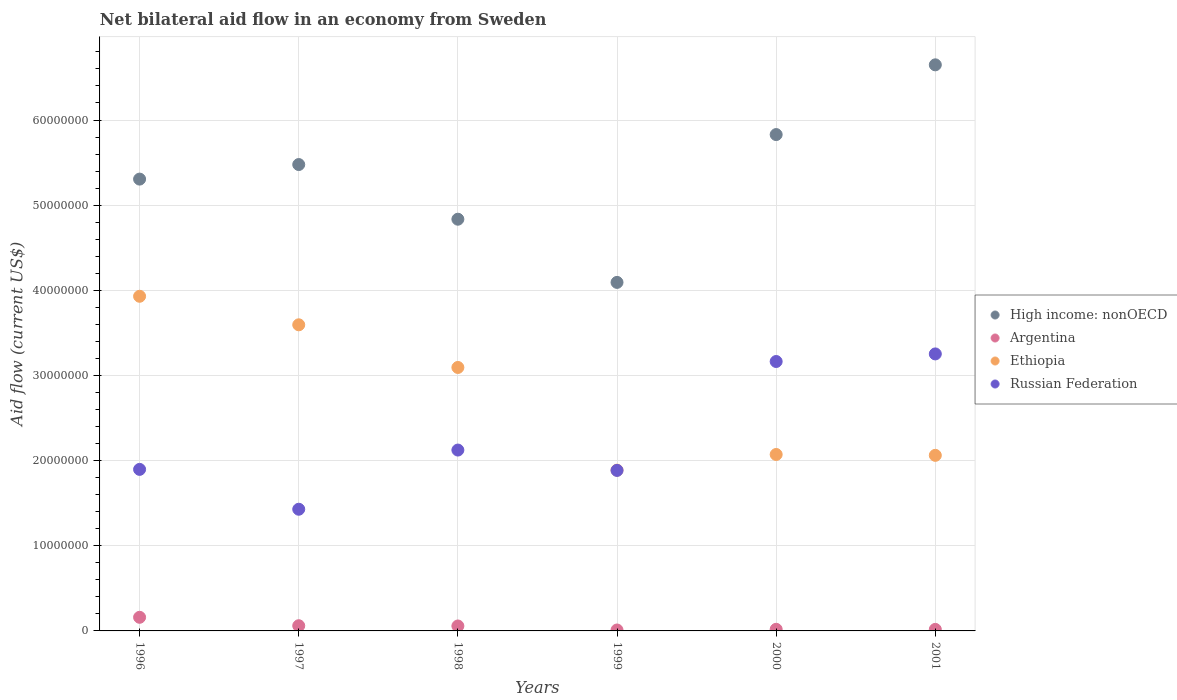How many different coloured dotlines are there?
Offer a very short reply. 4. Is the number of dotlines equal to the number of legend labels?
Make the answer very short. Yes. What is the net bilateral aid flow in Ethiopia in 2000?
Provide a short and direct response. 2.07e+07. Across all years, what is the maximum net bilateral aid flow in Ethiopia?
Offer a terse response. 3.93e+07. Across all years, what is the minimum net bilateral aid flow in High income: nonOECD?
Your response must be concise. 4.09e+07. In which year was the net bilateral aid flow in Ethiopia maximum?
Offer a very short reply. 1996. In which year was the net bilateral aid flow in Argentina minimum?
Offer a very short reply. 1999. What is the total net bilateral aid flow in Ethiopia in the graph?
Ensure brevity in your answer.  1.66e+08. What is the difference between the net bilateral aid flow in High income: nonOECD in 1999 and the net bilateral aid flow in Ethiopia in 1996?
Give a very brief answer. 1.63e+06. What is the average net bilateral aid flow in High income: nonOECD per year?
Your answer should be compact. 5.36e+07. In the year 1999, what is the difference between the net bilateral aid flow in Russian Federation and net bilateral aid flow in Argentina?
Give a very brief answer. 1.87e+07. What is the ratio of the net bilateral aid flow in Russian Federation in 1996 to that in 2000?
Ensure brevity in your answer.  0.6. What is the difference between the highest and the second highest net bilateral aid flow in High income: nonOECD?
Your answer should be very brief. 8.19e+06. What is the difference between the highest and the lowest net bilateral aid flow in Ethiopia?
Your response must be concise. 2.04e+07. In how many years, is the net bilateral aid flow in High income: nonOECD greater than the average net bilateral aid flow in High income: nonOECD taken over all years?
Provide a succinct answer. 3. Is the sum of the net bilateral aid flow in High income: nonOECD in 1996 and 1999 greater than the maximum net bilateral aid flow in Argentina across all years?
Provide a short and direct response. Yes. Is the net bilateral aid flow in Argentina strictly greater than the net bilateral aid flow in High income: nonOECD over the years?
Offer a terse response. No. Is the net bilateral aid flow in Russian Federation strictly less than the net bilateral aid flow in High income: nonOECD over the years?
Offer a terse response. Yes. How many dotlines are there?
Give a very brief answer. 4. How many years are there in the graph?
Keep it short and to the point. 6. Are the values on the major ticks of Y-axis written in scientific E-notation?
Give a very brief answer. No. Does the graph contain grids?
Make the answer very short. Yes. How are the legend labels stacked?
Your response must be concise. Vertical. What is the title of the graph?
Your answer should be compact. Net bilateral aid flow in an economy from Sweden. Does "Haiti" appear as one of the legend labels in the graph?
Provide a succinct answer. No. What is the label or title of the Y-axis?
Provide a short and direct response. Aid flow (current US$). What is the Aid flow (current US$) of High income: nonOECD in 1996?
Offer a terse response. 5.31e+07. What is the Aid flow (current US$) of Argentina in 1996?
Offer a terse response. 1.60e+06. What is the Aid flow (current US$) in Ethiopia in 1996?
Give a very brief answer. 3.93e+07. What is the Aid flow (current US$) in Russian Federation in 1996?
Offer a terse response. 1.90e+07. What is the Aid flow (current US$) of High income: nonOECD in 1997?
Make the answer very short. 5.48e+07. What is the Aid flow (current US$) in Ethiopia in 1997?
Your response must be concise. 3.60e+07. What is the Aid flow (current US$) in Russian Federation in 1997?
Offer a very short reply. 1.43e+07. What is the Aid flow (current US$) of High income: nonOECD in 1998?
Offer a terse response. 4.84e+07. What is the Aid flow (current US$) in Argentina in 1998?
Your answer should be very brief. 5.80e+05. What is the Aid flow (current US$) in Ethiopia in 1998?
Offer a terse response. 3.09e+07. What is the Aid flow (current US$) of Russian Federation in 1998?
Make the answer very short. 2.12e+07. What is the Aid flow (current US$) in High income: nonOECD in 1999?
Ensure brevity in your answer.  4.09e+07. What is the Aid flow (current US$) of Ethiopia in 1999?
Make the answer very short. 1.89e+07. What is the Aid flow (current US$) in Russian Federation in 1999?
Ensure brevity in your answer.  1.88e+07. What is the Aid flow (current US$) of High income: nonOECD in 2000?
Provide a short and direct response. 5.83e+07. What is the Aid flow (current US$) in Ethiopia in 2000?
Ensure brevity in your answer.  2.07e+07. What is the Aid flow (current US$) of Russian Federation in 2000?
Ensure brevity in your answer.  3.16e+07. What is the Aid flow (current US$) in High income: nonOECD in 2001?
Provide a succinct answer. 6.65e+07. What is the Aid flow (current US$) of Argentina in 2001?
Keep it short and to the point. 1.80e+05. What is the Aid flow (current US$) of Ethiopia in 2001?
Your answer should be compact. 2.06e+07. What is the Aid flow (current US$) in Russian Federation in 2001?
Provide a succinct answer. 3.25e+07. Across all years, what is the maximum Aid flow (current US$) in High income: nonOECD?
Your answer should be compact. 6.65e+07. Across all years, what is the maximum Aid flow (current US$) in Argentina?
Your answer should be very brief. 1.60e+06. Across all years, what is the maximum Aid flow (current US$) of Ethiopia?
Provide a short and direct response. 3.93e+07. Across all years, what is the maximum Aid flow (current US$) in Russian Federation?
Ensure brevity in your answer.  3.25e+07. Across all years, what is the minimum Aid flow (current US$) in High income: nonOECD?
Make the answer very short. 4.09e+07. Across all years, what is the minimum Aid flow (current US$) in Ethiopia?
Offer a terse response. 1.89e+07. Across all years, what is the minimum Aid flow (current US$) in Russian Federation?
Ensure brevity in your answer.  1.43e+07. What is the total Aid flow (current US$) in High income: nonOECD in the graph?
Your response must be concise. 3.22e+08. What is the total Aid flow (current US$) in Argentina in the graph?
Make the answer very short. 3.27e+06. What is the total Aid flow (current US$) of Ethiopia in the graph?
Your response must be concise. 1.66e+08. What is the total Aid flow (current US$) in Russian Federation in the graph?
Your answer should be very brief. 1.38e+08. What is the difference between the Aid flow (current US$) of High income: nonOECD in 1996 and that in 1997?
Your answer should be very brief. -1.71e+06. What is the difference between the Aid flow (current US$) of Argentina in 1996 and that in 1997?
Your answer should be very brief. 9.90e+05. What is the difference between the Aid flow (current US$) of Ethiopia in 1996 and that in 1997?
Your answer should be compact. 3.35e+06. What is the difference between the Aid flow (current US$) in Russian Federation in 1996 and that in 1997?
Offer a terse response. 4.68e+06. What is the difference between the Aid flow (current US$) of High income: nonOECD in 1996 and that in 1998?
Your answer should be compact. 4.71e+06. What is the difference between the Aid flow (current US$) in Argentina in 1996 and that in 1998?
Keep it short and to the point. 1.02e+06. What is the difference between the Aid flow (current US$) of Ethiopia in 1996 and that in 1998?
Ensure brevity in your answer.  8.36e+06. What is the difference between the Aid flow (current US$) of Russian Federation in 1996 and that in 1998?
Your response must be concise. -2.27e+06. What is the difference between the Aid flow (current US$) of High income: nonOECD in 1996 and that in 1999?
Make the answer very short. 1.21e+07. What is the difference between the Aid flow (current US$) of Argentina in 1996 and that in 1999?
Your answer should be very brief. 1.49e+06. What is the difference between the Aid flow (current US$) of Ethiopia in 1996 and that in 1999?
Your response must be concise. 2.04e+07. What is the difference between the Aid flow (current US$) in Russian Federation in 1996 and that in 1999?
Your answer should be very brief. 1.20e+05. What is the difference between the Aid flow (current US$) of High income: nonOECD in 1996 and that in 2000?
Provide a short and direct response. -5.23e+06. What is the difference between the Aid flow (current US$) of Argentina in 1996 and that in 2000?
Your response must be concise. 1.41e+06. What is the difference between the Aid flow (current US$) of Ethiopia in 1996 and that in 2000?
Provide a short and direct response. 1.86e+07. What is the difference between the Aid flow (current US$) of Russian Federation in 1996 and that in 2000?
Make the answer very short. -1.27e+07. What is the difference between the Aid flow (current US$) of High income: nonOECD in 1996 and that in 2001?
Provide a short and direct response. -1.34e+07. What is the difference between the Aid flow (current US$) of Argentina in 1996 and that in 2001?
Make the answer very short. 1.42e+06. What is the difference between the Aid flow (current US$) of Ethiopia in 1996 and that in 2001?
Offer a terse response. 1.87e+07. What is the difference between the Aid flow (current US$) of Russian Federation in 1996 and that in 2001?
Offer a terse response. -1.36e+07. What is the difference between the Aid flow (current US$) of High income: nonOECD in 1997 and that in 1998?
Provide a short and direct response. 6.42e+06. What is the difference between the Aid flow (current US$) in Ethiopia in 1997 and that in 1998?
Your answer should be very brief. 5.01e+06. What is the difference between the Aid flow (current US$) in Russian Federation in 1997 and that in 1998?
Give a very brief answer. -6.95e+06. What is the difference between the Aid flow (current US$) in High income: nonOECD in 1997 and that in 1999?
Your answer should be very brief. 1.38e+07. What is the difference between the Aid flow (current US$) in Ethiopia in 1997 and that in 1999?
Ensure brevity in your answer.  1.71e+07. What is the difference between the Aid flow (current US$) in Russian Federation in 1997 and that in 1999?
Offer a terse response. -4.56e+06. What is the difference between the Aid flow (current US$) in High income: nonOECD in 1997 and that in 2000?
Offer a terse response. -3.52e+06. What is the difference between the Aid flow (current US$) of Ethiopia in 1997 and that in 2000?
Give a very brief answer. 1.52e+07. What is the difference between the Aid flow (current US$) in Russian Federation in 1997 and that in 2000?
Keep it short and to the point. -1.74e+07. What is the difference between the Aid flow (current US$) of High income: nonOECD in 1997 and that in 2001?
Ensure brevity in your answer.  -1.17e+07. What is the difference between the Aid flow (current US$) in Ethiopia in 1997 and that in 2001?
Your response must be concise. 1.53e+07. What is the difference between the Aid flow (current US$) in Russian Federation in 1997 and that in 2001?
Offer a very short reply. -1.82e+07. What is the difference between the Aid flow (current US$) of High income: nonOECD in 1998 and that in 1999?
Give a very brief answer. 7.42e+06. What is the difference between the Aid flow (current US$) in Argentina in 1998 and that in 1999?
Keep it short and to the point. 4.70e+05. What is the difference between the Aid flow (current US$) of Ethiopia in 1998 and that in 1999?
Give a very brief answer. 1.21e+07. What is the difference between the Aid flow (current US$) of Russian Federation in 1998 and that in 1999?
Make the answer very short. 2.39e+06. What is the difference between the Aid flow (current US$) of High income: nonOECD in 1998 and that in 2000?
Your response must be concise. -9.94e+06. What is the difference between the Aid flow (current US$) of Argentina in 1998 and that in 2000?
Keep it short and to the point. 3.90e+05. What is the difference between the Aid flow (current US$) of Ethiopia in 1998 and that in 2000?
Keep it short and to the point. 1.02e+07. What is the difference between the Aid flow (current US$) of Russian Federation in 1998 and that in 2000?
Keep it short and to the point. -1.04e+07. What is the difference between the Aid flow (current US$) in High income: nonOECD in 1998 and that in 2001?
Your response must be concise. -1.81e+07. What is the difference between the Aid flow (current US$) in Ethiopia in 1998 and that in 2001?
Your answer should be compact. 1.03e+07. What is the difference between the Aid flow (current US$) in Russian Federation in 1998 and that in 2001?
Provide a short and direct response. -1.13e+07. What is the difference between the Aid flow (current US$) of High income: nonOECD in 1999 and that in 2000?
Provide a succinct answer. -1.74e+07. What is the difference between the Aid flow (current US$) in Ethiopia in 1999 and that in 2000?
Your answer should be compact. -1.84e+06. What is the difference between the Aid flow (current US$) of Russian Federation in 1999 and that in 2000?
Make the answer very short. -1.28e+07. What is the difference between the Aid flow (current US$) in High income: nonOECD in 1999 and that in 2001?
Your response must be concise. -2.56e+07. What is the difference between the Aid flow (current US$) in Argentina in 1999 and that in 2001?
Provide a short and direct response. -7.00e+04. What is the difference between the Aid flow (current US$) of Ethiopia in 1999 and that in 2001?
Provide a succinct answer. -1.74e+06. What is the difference between the Aid flow (current US$) in Russian Federation in 1999 and that in 2001?
Keep it short and to the point. -1.37e+07. What is the difference between the Aid flow (current US$) of High income: nonOECD in 2000 and that in 2001?
Offer a very short reply. -8.19e+06. What is the difference between the Aid flow (current US$) of Argentina in 2000 and that in 2001?
Provide a short and direct response. 10000. What is the difference between the Aid flow (current US$) in Ethiopia in 2000 and that in 2001?
Make the answer very short. 1.00e+05. What is the difference between the Aid flow (current US$) of Russian Federation in 2000 and that in 2001?
Your answer should be very brief. -8.90e+05. What is the difference between the Aid flow (current US$) in High income: nonOECD in 1996 and the Aid flow (current US$) in Argentina in 1997?
Your answer should be very brief. 5.24e+07. What is the difference between the Aid flow (current US$) in High income: nonOECD in 1996 and the Aid flow (current US$) in Ethiopia in 1997?
Make the answer very short. 1.71e+07. What is the difference between the Aid flow (current US$) in High income: nonOECD in 1996 and the Aid flow (current US$) in Russian Federation in 1997?
Make the answer very short. 3.88e+07. What is the difference between the Aid flow (current US$) of Argentina in 1996 and the Aid flow (current US$) of Ethiopia in 1997?
Offer a terse response. -3.44e+07. What is the difference between the Aid flow (current US$) in Argentina in 1996 and the Aid flow (current US$) in Russian Federation in 1997?
Offer a very short reply. -1.27e+07. What is the difference between the Aid flow (current US$) in Ethiopia in 1996 and the Aid flow (current US$) in Russian Federation in 1997?
Ensure brevity in your answer.  2.50e+07. What is the difference between the Aid flow (current US$) in High income: nonOECD in 1996 and the Aid flow (current US$) in Argentina in 1998?
Your response must be concise. 5.25e+07. What is the difference between the Aid flow (current US$) in High income: nonOECD in 1996 and the Aid flow (current US$) in Ethiopia in 1998?
Your answer should be compact. 2.21e+07. What is the difference between the Aid flow (current US$) of High income: nonOECD in 1996 and the Aid flow (current US$) of Russian Federation in 1998?
Offer a very short reply. 3.18e+07. What is the difference between the Aid flow (current US$) of Argentina in 1996 and the Aid flow (current US$) of Ethiopia in 1998?
Make the answer very short. -2.93e+07. What is the difference between the Aid flow (current US$) of Argentina in 1996 and the Aid flow (current US$) of Russian Federation in 1998?
Give a very brief answer. -1.96e+07. What is the difference between the Aid flow (current US$) in Ethiopia in 1996 and the Aid flow (current US$) in Russian Federation in 1998?
Ensure brevity in your answer.  1.81e+07. What is the difference between the Aid flow (current US$) in High income: nonOECD in 1996 and the Aid flow (current US$) in Argentina in 1999?
Offer a very short reply. 5.30e+07. What is the difference between the Aid flow (current US$) in High income: nonOECD in 1996 and the Aid flow (current US$) in Ethiopia in 1999?
Keep it short and to the point. 3.42e+07. What is the difference between the Aid flow (current US$) of High income: nonOECD in 1996 and the Aid flow (current US$) of Russian Federation in 1999?
Give a very brief answer. 3.42e+07. What is the difference between the Aid flow (current US$) of Argentina in 1996 and the Aid flow (current US$) of Ethiopia in 1999?
Provide a succinct answer. -1.73e+07. What is the difference between the Aid flow (current US$) in Argentina in 1996 and the Aid flow (current US$) in Russian Federation in 1999?
Your response must be concise. -1.72e+07. What is the difference between the Aid flow (current US$) of Ethiopia in 1996 and the Aid flow (current US$) of Russian Federation in 1999?
Offer a very short reply. 2.04e+07. What is the difference between the Aid flow (current US$) in High income: nonOECD in 1996 and the Aid flow (current US$) in Argentina in 2000?
Your answer should be compact. 5.29e+07. What is the difference between the Aid flow (current US$) of High income: nonOECD in 1996 and the Aid flow (current US$) of Ethiopia in 2000?
Offer a terse response. 3.23e+07. What is the difference between the Aid flow (current US$) of High income: nonOECD in 1996 and the Aid flow (current US$) of Russian Federation in 2000?
Provide a short and direct response. 2.14e+07. What is the difference between the Aid flow (current US$) in Argentina in 1996 and the Aid flow (current US$) in Ethiopia in 2000?
Make the answer very short. -1.91e+07. What is the difference between the Aid flow (current US$) of Argentina in 1996 and the Aid flow (current US$) of Russian Federation in 2000?
Your answer should be very brief. -3.00e+07. What is the difference between the Aid flow (current US$) in Ethiopia in 1996 and the Aid flow (current US$) in Russian Federation in 2000?
Provide a short and direct response. 7.66e+06. What is the difference between the Aid flow (current US$) of High income: nonOECD in 1996 and the Aid flow (current US$) of Argentina in 2001?
Give a very brief answer. 5.29e+07. What is the difference between the Aid flow (current US$) in High income: nonOECD in 1996 and the Aid flow (current US$) in Ethiopia in 2001?
Give a very brief answer. 3.24e+07. What is the difference between the Aid flow (current US$) in High income: nonOECD in 1996 and the Aid flow (current US$) in Russian Federation in 2001?
Offer a terse response. 2.05e+07. What is the difference between the Aid flow (current US$) of Argentina in 1996 and the Aid flow (current US$) of Ethiopia in 2001?
Offer a very short reply. -1.90e+07. What is the difference between the Aid flow (current US$) of Argentina in 1996 and the Aid flow (current US$) of Russian Federation in 2001?
Your answer should be compact. -3.09e+07. What is the difference between the Aid flow (current US$) in Ethiopia in 1996 and the Aid flow (current US$) in Russian Federation in 2001?
Ensure brevity in your answer.  6.77e+06. What is the difference between the Aid flow (current US$) in High income: nonOECD in 1997 and the Aid flow (current US$) in Argentina in 1998?
Provide a short and direct response. 5.42e+07. What is the difference between the Aid flow (current US$) in High income: nonOECD in 1997 and the Aid flow (current US$) in Ethiopia in 1998?
Ensure brevity in your answer.  2.38e+07. What is the difference between the Aid flow (current US$) in High income: nonOECD in 1997 and the Aid flow (current US$) in Russian Federation in 1998?
Your answer should be very brief. 3.35e+07. What is the difference between the Aid flow (current US$) in Argentina in 1997 and the Aid flow (current US$) in Ethiopia in 1998?
Offer a terse response. -3.03e+07. What is the difference between the Aid flow (current US$) of Argentina in 1997 and the Aid flow (current US$) of Russian Federation in 1998?
Make the answer very short. -2.06e+07. What is the difference between the Aid flow (current US$) of Ethiopia in 1997 and the Aid flow (current US$) of Russian Federation in 1998?
Provide a short and direct response. 1.47e+07. What is the difference between the Aid flow (current US$) of High income: nonOECD in 1997 and the Aid flow (current US$) of Argentina in 1999?
Provide a short and direct response. 5.47e+07. What is the difference between the Aid flow (current US$) in High income: nonOECD in 1997 and the Aid flow (current US$) in Ethiopia in 1999?
Offer a very short reply. 3.59e+07. What is the difference between the Aid flow (current US$) in High income: nonOECD in 1997 and the Aid flow (current US$) in Russian Federation in 1999?
Make the answer very short. 3.59e+07. What is the difference between the Aid flow (current US$) of Argentina in 1997 and the Aid flow (current US$) of Ethiopia in 1999?
Keep it short and to the point. -1.83e+07. What is the difference between the Aid flow (current US$) of Argentina in 1997 and the Aid flow (current US$) of Russian Federation in 1999?
Make the answer very short. -1.82e+07. What is the difference between the Aid flow (current US$) of Ethiopia in 1997 and the Aid flow (current US$) of Russian Federation in 1999?
Offer a terse response. 1.71e+07. What is the difference between the Aid flow (current US$) of High income: nonOECD in 1997 and the Aid flow (current US$) of Argentina in 2000?
Offer a very short reply. 5.46e+07. What is the difference between the Aid flow (current US$) in High income: nonOECD in 1997 and the Aid flow (current US$) in Ethiopia in 2000?
Offer a terse response. 3.40e+07. What is the difference between the Aid flow (current US$) of High income: nonOECD in 1997 and the Aid flow (current US$) of Russian Federation in 2000?
Make the answer very short. 2.31e+07. What is the difference between the Aid flow (current US$) of Argentina in 1997 and the Aid flow (current US$) of Ethiopia in 2000?
Provide a short and direct response. -2.01e+07. What is the difference between the Aid flow (current US$) in Argentina in 1997 and the Aid flow (current US$) in Russian Federation in 2000?
Give a very brief answer. -3.10e+07. What is the difference between the Aid flow (current US$) in Ethiopia in 1997 and the Aid flow (current US$) in Russian Federation in 2000?
Offer a very short reply. 4.31e+06. What is the difference between the Aid flow (current US$) in High income: nonOECD in 1997 and the Aid flow (current US$) in Argentina in 2001?
Make the answer very short. 5.46e+07. What is the difference between the Aid flow (current US$) of High income: nonOECD in 1997 and the Aid flow (current US$) of Ethiopia in 2001?
Offer a terse response. 3.42e+07. What is the difference between the Aid flow (current US$) of High income: nonOECD in 1997 and the Aid flow (current US$) of Russian Federation in 2001?
Keep it short and to the point. 2.22e+07. What is the difference between the Aid flow (current US$) of Argentina in 1997 and the Aid flow (current US$) of Ethiopia in 2001?
Offer a terse response. -2.00e+07. What is the difference between the Aid flow (current US$) in Argentina in 1997 and the Aid flow (current US$) in Russian Federation in 2001?
Give a very brief answer. -3.19e+07. What is the difference between the Aid flow (current US$) of Ethiopia in 1997 and the Aid flow (current US$) of Russian Federation in 2001?
Provide a succinct answer. 3.42e+06. What is the difference between the Aid flow (current US$) in High income: nonOECD in 1998 and the Aid flow (current US$) in Argentina in 1999?
Offer a very short reply. 4.82e+07. What is the difference between the Aid flow (current US$) of High income: nonOECD in 1998 and the Aid flow (current US$) of Ethiopia in 1999?
Your response must be concise. 2.95e+07. What is the difference between the Aid flow (current US$) of High income: nonOECD in 1998 and the Aid flow (current US$) of Russian Federation in 1999?
Give a very brief answer. 2.95e+07. What is the difference between the Aid flow (current US$) of Argentina in 1998 and the Aid flow (current US$) of Ethiopia in 1999?
Provide a short and direct response. -1.83e+07. What is the difference between the Aid flow (current US$) in Argentina in 1998 and the Aid flow (current US$) in Russian Federation in 1999?
Ensure brevity in your answer.  -1.83e+07. What is the difference between the Aid flow (current US$) in Ethiopia in 1998 and the Aid flow (current US$) in Russian Federation in 1999?
Offer a terse response. 1.21e+07. What is the difference between the Aid flow (current US$) in High income: nonOECD in 1998 and the Aid flow (current US$) in Argentina in 2000?
Make the answer very short. 4.82e+07. What is the difference between the Aid flow (current US$) in High income: nonOECD in 1998 and the Aid flow (current US$) in Ethiopia in 2000?
Provide a succinct answer. 2.76e+07. What is the difference between the Aid flow (current US$) of High income: nonOECD in 1998 and the Aid flow (current US$) of Russian Federation in 2000?
Provide a succinct answer. 1.67e+07. What is the difference between the Aid flow (current US$) of Argentina in 1998 and the Aid flow (current US$) of Ethiopia in 2000?
Keep it short and to the point. -2.01e+07. What is the difference between the Aid flow (current US$) of Argentina in 1998 and the Aid flow (current US$) of Russian Federation in 2000?
Ensure brevity in your answer.  -3.11e+07. What is the difference between the Aid flow (current US$) in Ethiopia in 1998 and the Aid flow (current US$) in Russian Federation in 2000?
Make the answer very short. -7.00e+05. What is the difference between the Aid flow (current US$) in High income: nonOECD in 1998 and the Aid flow (current US$) in Argentina in 2001?
Your answer should be compact. 4.82e+07. What is the difference between the Aid flow (current US$) of High income: nonOECD in 1998 and the Aid flow (current US$) of Ethiopia in 2001?
Offer a very short reply. 2.77e+07. What is the difference between the Aid flow (current US$) in High income: nonOECD in 1998 and the Aid flow (current US$) in Russian Federation in 2001?
Make the answer very short. 1.58e+07. What is the difference between the Aid flow (current US$) in Argentina in 1998 and the Aid flow (current US$) in Ethiopia in 2001?
Keep it short and to the point. -2.00e+07. What is the difference between the Aid flow (current US$) in Argentina in 1998 and the Aid flow (current US$) in Russian Federation in 2001?
Provide a short and direct response. -3.20e+07. What is the difference between the Aid flow (current US$) in Ethiopia in 1998 and the Aid flow (current US$) in Russian Federation in 2001?
Ensure brevity in your answer.  -1.59e+06. What is the difference between the Aid flow (current US$) in High income: nonOECD in 1999 and the Aid flow (current US$) in Argentina in 2000?
Your answer should be very brief. 4.07e+07. What is the difference between the Aid flow (current US$) of High income: nonOECD in 1999 and the Aid flow (current US$) of Ethiopia in 2000?
Give a very brief answer. 2.02e+07. What is the difference between the Aid flow (current US$) of High income: nonOECD in 1999 and the Aid flow (current US$) of Russian Federation in 2000?
Provide a short and direct response. 9.29e+06. What is the difference between the Aid flow (current US$) of Argentina in 1999 and the Aid flow (current US$) of Ethiopia in 2000?
Ensure brevity in your answer.  -2.06e+07. What is the difference between the Aid flow (current US$) in Argentina in 1999 and the Aid flow (current US$) in Russian Federation in 2000?
Provide a succinct answer. -3.15e+07. What is the difference between the Aid flow (current US$) of Ethiopia in 1999 and the Aid flow (current US$) of Russian Federation in 2000?
Make the answer very short. -1.28e+07. What is the difference between the Aid flow (current US$) in High income: nonOECD in 1999 and the Aid flow (current US$) in Argentina in 2001?
Keep it short and to the point. 4.08e+07. What is the difference between the Aid flow (current US$) of High income: nonOECD in 1999 and the Aid flow (current US$) of Ethiopia in 2001?
Provide a short and direct response. 2.03e+07. What is the difference between the Aid flow (current US$) in High income: nonOECD in 1999 and the Aid flow (current US$) in Russian Federation in 2001?
Make the answer very short. 8.40e+06. What is the difference between the Aid flow (current US$) of Argentina in 1999 and the Aid flow (current US$) of Ethiopia in 2001?
Provide a short and direct response. -2.05e+07. What is the difference between the Aid flow (current US$) of Argentina in 1999 and the Aid flow (current US$) of Russian Federation in 2001?
Offer a terse response. -3.24e+07. What is the difference between the Aid flow (current US$) in Ethiopia in 1999 and the Aid flow (current US$) in Russian Federation in 2001?
Provide a succinct answer. -1.36e+07. What is the difference between the Aid flow (current US$) in High income: nonOECD in 2000 and the Aid flow (current US$) in Argentina in 2001?
Provide a short and direct response. 5.81e+07. What is the difference between the Aid flow (current US$) of High income: nonOECD in 2000 and the Aid flow (current US$) of Ethiopia in 2001?
Provide a succinct answer. 3.77e+07. What is the difference between the Aid flow (current US$) in High income: nonOECD in 2000 and the Aid flow (current US$) in Russian Federation in 2001?
Give a very brief answer. 2.58e+07. What is the difference between the Aid flow (current US$) of Argentina in 2000 and the Aid flow (current US$) of Ethiopia in 2001?
Your response must be concise. -2.04e+07. What is the difference between the Aid flow (current US$) of Argentina in 2000 and the Aid flow (current US$) of Russian Federation in 2001?
Give a very brief answer. -3.23e+07. What is the difference between the Aid flow (current US$) in Ethiopia in 2000 and the Aid flow (current US$) in Russian Federation in 2001?
Ensure brevity in your answer.  -1.18e+07. What is the average Aid flow (current US$) of High income: nonOECD per year?
Offer a terse response. 5.36e+07. What is the average Aid flow (current US$) of Argentina per year?
Offer a very short reply. 5.45e+05. What is the average Aid flow (current US$) in Ethiopia per year?
Keep it short and to the point. 2.77e+07. What is the average Aid flow (current US$) of Russian Federation per year?
Your answer should be compact. 2.29e+07. In the year 1996, what is the difference between the Aid flow (current US$) of High income: nonOECD and Aid flow (current US$) of Argentina?
Provide a succinct answer. 5.15e+07. In the year 1996, what is the difference between the Aid flow (current US$) of High income: nonOECD and Aid flow (current US$) of Ethiopia?
Provide a short and direct response. 1.38e+07. In the year 1996, what is the difference between the Aid flow (current US$) of High income: nonOECD and Aid flow (current US$) of Russian Federation?
Your response must be concise. 3.41e+07. In the year 1996, what is the difference between the Aid flow (current US$) in Argentina and Aid flow (current US$) in Ethiopia?
Your answer should be compact. -3.77e+07. In the year 1996, what is the difference between the Aid flow (current US$) of Argentina and Aid flow (current US$) of Russian Federation?
Your response must be concise. -1.74e+07. In the year 1996, what is the difference between the Aid flow (current US$) of Ethiopia and Aid flow (current US$) of Russian Federation?
Offer a very short reply. 2.03e+07. In the year 1997, what is the difference between the Aid flow (current US$) in High income: nonOECD and Aid flow (current US$) in Argentina?
Your answer should be very brief. 5.42e+07. In the year 1997, what is the difference between the Aid flow (current US$) in High income: nonOECD and Aid flow (current US$) in Ethiopia?
Your answer should be compact. 1.88e+07. In the year 1997, what is the difference between the Aid flow (current US$) in High income: nonOECD and Aid flow (current US$) in Russian Federation?
Give a very brief answer. 4.05e+07. In the year 1997, what is the difference between the Aid flow (current US$) in Argentina and Aid flow (current US$) in Ethiopia?
Your answer should be very brief. -3.53e+07. In the year 1997, what is the difference between the Aid flow (current US$) of Argentina and Aid flow (current US$) of Russian Federation?
Your response must be concise. -1.37e+07. In the year 1997, what is the difference between the Aid flow (current US$) in Ethiopia and Aid flow (current US$) in Russian Federation?
Provide a succinct answer. 2.17e+07. In the year 1998, what is the difference between the Aid flow (current US$) of High income: nonOECD and Aid flow (current US$) of Argentina?
Offer a very short reply. 4.78e+07. In the year 1998, what is the difference between the Aid flow (current US$) in High income: nonOECD and Aid flow (current US$) in Ethiopia?
Your answer should be compact. 1.74e+07. In the year 1998, what is the difference between the Aid flow (current US$) of High income: nonOECD and Aid flow (current US$) of Russian Federation?
Keep it short and to the point. 2.71e+07. In the year 1998, what is the difference between the Aid flow (current US$) in Argentina and Aid flow (current US$) in Ethiopia?
Ensure brevity in your answer.  -3.04e+07. In the year 1998, what is the difference between the Aid flow (current US$) of Argentina and Aid flow (current US$) of Russian Federation?
Give a very brief answer. -2.07e+07. In the year 1998, what is the difference between the Aid flow (current US$) of Ethiopia and Aid flow (current US$) of Russian Federation?
Make the answer very short. 9.70e+06. In the year 1999, what is the difference between the Aid flow (current US$) of High income: nonOECD and Aid flow (current US$) of Argentina?
Provide a succinct answer. 4.08e+07. In the year 1999, what is the difference between the Aid flow (current US$) in High income: nonOECD and Aid flow (current US$) in Ethiopia?
Give a very brief answer. 2.20e+07. In the year 1999, what is the difference between the Aid flow (current US$) in High income: nonOECD and Aid flow (current US$) in Russian Federation?
Offer a very short reply. 2.21e+07. In the year 1999, what is the difference between the Aid flow (current US$) of Argentina and Aid flow (current US$) of Ethiopia?
Provide a succinct answer. -1.88e+07. In the year 1999, what is the difference between the Aid flow (current US$) in Argentina and Aid flow (current US$) in Russian Federation?
Offer a terse response. -1.87e+07. In the year 1999, what is the difference between the Aid flow (current US$) of Ethiopia and Aid flow (current US$) of Russian Federation?
Offer a terse response. 3.00e+04. In the year 2000, what is the difference between the Aid flow (current US$) in High income: nonOECD and Aid flow (current US$) in Argentina?
Give a very brief answer. 5.81e+07. In the year 2000, what is the difference between the Aid flow (current US$) in High income: nonOECD and Aid flow (current US$) in Ethiopia?
Give a very brief answer. 3.76e+07. In the year 2000, what is the difference between the Aid flow (current US$) in High income: nonOECD and Aid flow (current US$) in Russian Federation?
Your answer should be very brief. 2.66e+07. In the year 2000, what is the difference between the Aid flow (current US$) in Argentina and Aid flow (current US$) in Ethiopia?
Offer a very short reply. -2.05e+07. In the year 2000, what is the difference between the Aid flow (current US$) of Argentina and Aid flow (current US$) of Russian Federation?
Keep it short and to the point. -3.14e+07. In the year 2000, what is the difference between the Aid flow (current US$) of Ethiopia and Aid flow (current US$) of Russian Federation?
Make the answer very short. -1.09e+07. In the year 2001, what is the difference between the Aid flow (current US$) in High income: nonOECD and Aid flow (current US$) in Argentina?
Offer a terse response. 6.63e+07. In the year 2001, what is the difference between the Aid flow (current US$) of High income: nonOECD and Aid flow (current US$) of Ethiopia?
Offer a terse response. 4.59e+07. In the year 2001, what is the difference between the Aid flow (current US$) in High income: nonOECD and Aid flow (current US$) in Russian Federation?
Make the answer very short. 3.40e+07. In the year 2001, what is the difference between the Aid flow (current US$) in Argentina and Aid flow (current US$) in Ethiopia?
Your answer should be very brief. -2.04e+07. In the year 2001, what is the difference between the Aid flow (current US$) in Argentina and Aid flow (current US$) in Russian Federation?
Your response must be concise. -3.24e+07. In the year 2001, what is the difference between the Aid flow (current US$) of Ethiopia and Aid flow (current US$) of Russian Federation?
Offer a very short reply. -1.19e+07. What is the ratio of the Aid flow (current US$) in High income: nonOECD in 1996 to that in 1997?
Your answer should be compact. 0.97. What is the ratio of the Aid flow (current US$) in Argentina in 1996 to that in 1997?
Provide a short and direct response. 2.62. What is the ratio of the Aid flow (current US$) in Ethiopia in 1996 to that in 1997?
Your answer should be very brief. 1.09. What is the ratio of the Aid flow (current US$) in Russian Federation in 1996 to that in 1997?
Make the answer very short. 1.33. What is the ratio of the Aid flow (current US$) of High income: nonOECD in 1996 to that in 1998?
Ensure brevity in your answer.  1.1. What is the ratio of the Aid flow (current US$) of Argentina in 1996 to that in 1998?
Ensure brevity in your answer.  2.76. What is the ratio of the Aid flow (current US$) of Ethiopia in 1996 to that in 1998?
Your answer should be very brief. 1.27. What is the ratio of the Aid flow (current US$) of Russian Federation in 1996 to that in 1998?
Provide a succinct answer. 0.89. What is the ratio of the Aid flow (current US$) of High income: nonOECD in 1996 to that in 1999?
Offer a terse response. 1.3. What is the ratio of the Aid flow (current US$) of Argentina in 1996 to that in 1999?
Provide a short and direct response. 14.55. What is the ratio of the Aid flow (current US$) of Ethiopia in 1996 to that in 1999?
Offer a very short reply. 2.08. What is the ratio of the Aid flow (current US$) of Russian Federation in 1996 to that in 1999?
Offer a terse response. 1.01. What is the ratio of the Aid flow (current US$) of High income: nonOECD in 1996 to that in 2000?
Make the answer very short. 0.91. What is the ratio of the Aid flow (current US$) in Argentina in 1996 to that in 2000?
Give a very brief answer. 8.42. What is the ratio of the Aid flow (current US$) in Ethiopia in 1996 to that in 2000?
Your answer should be compact. 1.9. What is the ratio of the Aid flow (current US$) of Russian Federation in 1996 to that in 2000?
Provide a succinct answer. 0.6. What is the ratio of the Aid flow (current US$) of High income: nonOECD in 1996 to that in 2001?
Provide a succinct answer. 0.8. What is the ratio of the Aid flow (current US$) of Argentina in 1996 to that in 2001?
Your answer should be compact. 8.89. What is the ratio of the Aid flow (current US$) of Ethiopia in 1996 to that in 2001?
Make the answer very short. 1.91. What is the ratio of the Aid flow (current US$) of Russian Federation in 1996 to that in 2001?
Offer a terse response. 0.58. What is the ratio of the Aid flow (current US$) in High income: nonOECD in 1997 to that in 1998?
Make the answer very short. 1.13. What is the ratio of the Aid flow (current US$) in Argentina in 1997 to that in 1998?
Your response must be concise. 1.05. What is the ratio of the Aid flow (current US$) in Ethiopia in 1997 to that in 1998?
Your answer should be compact. 1.16. What is the ratio of the Aid flow (current US$) of Russian Federation in 1997 to that in 1998?
Provide a succinct answer. 0.67. What is the ratio of the Aid flow (current US$) in High income: nonOECD in 1997 to that in 1999?
Offer a very short reply. 1.34. What is the ratio of the Aid flow (current US$) of Argentina in 1997 to that in 1999?
Provide a short and direct response. 5.55. What is the ratio of the Aid flow (current US$) in Ethiopia in 1997 to that in 1999?
Provide a succinct answer. 1.9. What is the ratio of the Aid flow (current US$) of Russian Federation in 1997 to that in 1999?
Provide a succinct answer. 0.76. What is the ratio of the Aid flow (current US$) in High income: nonOECD in 1997 to that in 2000?
Your answer should be compact. 0.94. What is the ratio of the Aid flow (current US$) in Argentina in 1997 to that in 2000?
Keep it short and to the point. 3.21. What is the ratio of the Aid flow (current US$) in Ethiopia in 1997 to that in 2000?
Offer a very short reply. 1.74. What is the ratio of the Aid flow (current US$) of Russian Federation in 1997 to that in 2000?
Provide a short and direct response. 0.45. What is the ratio of the Aid flow (current US$) of High income: nonOECD in 1997 to that in 2001?
Your response must be concise. 0.82. What is the ratio of the Aid flow (current US$) in Argentina in 1997 to that in 2001?
Your answer should be compact. 3.39. What is the ratio of the Aid flow (current US$) of Ethiopia in 1997 to that in 2001?
Your answer should be compact. 1.74. What is the ratio of the Aid flow (current US$) of Russian Federation in 1997 to that in 2001?
Make the answer very short. 0.44. What is the ratio of the Aid flow (current US$) of High income: nonOECD in 1998 to that in 1999?
Provide a succinct answer. 1.18. What is the ratio of the Aid flow (current US$) of Argentina in 1998 to that in 1999?
Provide a short and direct response. 5.27. What is the ratio of the Aid flow (current US$) in Ethiopia in 1998 to that in 1999?
Provide a short and direct response. 1.64. What is the ratio of the Aid flow (current US$) in Russian Federation in 1998 to that in 1999?
Provide a short and direct response. 1.13. What is the ratio of the Aid flow (current US$) of High income: nonOECD in 1998 to that in 2000?
Give a very brief answer. 0.83. What is the ratio of the Aid flow (current US$) in Argentina in 1998 to that in 2000?
Offer a very short reply. 3.05. What is the ratio of the Aid flow (current US$) in Ethiopia in 1998 to that in 2000?
Make the answer very short. 1.49. What is the ratio of the Aid flow (current US$) in Russian Federation in 1998 to that in 2000?
Ensure brevity in your answer.  0.67. What is the ratio of the Aid flow (current US$) in High income: nonOECD in 1998 to that in 2001?
Provide a short and direct response. 0.73. What is the ratio of the Aid flow (current US$) in Argentina in 1998 to that in 2001?
Offer a terse response. 3.22. What is the ratio of the Aid flow (current US$) of Ethiopia in 1998 to that in 2001?
Give a very brief answer. 1.5. What is the ratio of the Aid flow (current US$) of Russian Federation in 1998 to that in 2001?
Ensure brevity in your answer.  0.65. What is the ratio of the Aid flow (current US$) in High income: nonOECD in 1999 to that in 2000?
Keep it short and to the point. 0.7. What is the ratio of the Aid flow (current US$) of Argentina in 1999 to that in 2000?
Your response must be concise. 0.58. What is the ratio of the Aid flow (current US$) of Ethiopia in 1999 to that in 2000?
Give a very brief answer. 0.91. What is the ratio of the Aid flow (current US$) in Russian Federation in 1999 to that in 2000?
Make the answer very short. 0.6. What is the ratio of the Aid flow (current US$) of High income: nonOECD in 1999 to that in 2001?
Offer a very short reply. 0.62. What is the ratio of the Aid flow (current US$) of Argentina in 1999 to that in 2001?
Make the answer very short. 0.61. What is the ratio of the Aid flow (current US$) of Ethiopia in 1999 to that in 2001?
Your answer should be compact. 0.92. What is the ratio of the Aid flow (current US$) of Russian Federation in 1999 to that in 2001?
Provide a short and direct response. 0.58. What is the ratio of the Aid flow (current US$) in High income: nonOECD in 2000 to that in 2001?
Ensure brevity in your answer.  0.88. What is the ratio of the Aid flow (current US$) in Argentina in 2000 to that in 2001?
Offer a terse response. 1.06. What is the ratio of the Aid flow (current US$) of Ethiopia in 2000 to that in 2001?
Provide a succinct answer. 1. What is the ratio of the Aid flow (current US$) in Russian Federation in 2000 to that in 2001?
Ensure brevity in your answer.  0.97. What is the difference between the highest and the second highest Aid flow (current US$) of High income: nonOECD?
Your answer should be compact. 8.19e+06. What is the difference between the highest and the second highest Aid flow (current US$) of Argentina?
Give a very brief answer. 9.90e+05. What is the difference between the highest and the second highest Aid flow (current US$) in Ethiopia?
Provide a succinct answer. 3.35e+06. What is the difference between the highest and the second highest Aid flow (current US$) of Russian Federation?
Give a very brief answer. 8.90e+05. What is the difference between the highest and the lowest Aid flow (current US$) in High income: nonOECD?
Offer a terse response. 2.56e+07. What is the difference between the highest and the lowest Aid flow (current US$) in Argentina?
Offer a very short reply. 1.49e+06. What is the difference between the highest and the lowest Aid flow (current US$) of Ethiopia?
Your answer should be very brief. 2.04e+07. What is the difference between the highest and the lowest Aid flow (current US$) of Russian Federation?
Ensure brevity in your answer.  1.82e+07. 